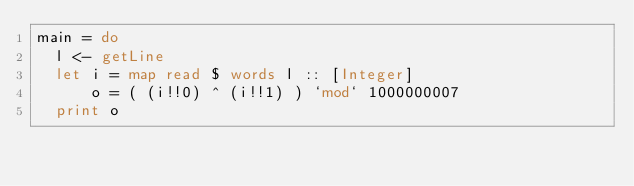Convert code to text. <code><loc_0><loc_0><loc_500><loc_500><_Haskell_>main = do
  l <- getLine
  let i = map read $ words l :: [Integer]
      o = ( (i!!0) ^ (i!!1) ) `mod` 1000000007
  print o</code> 